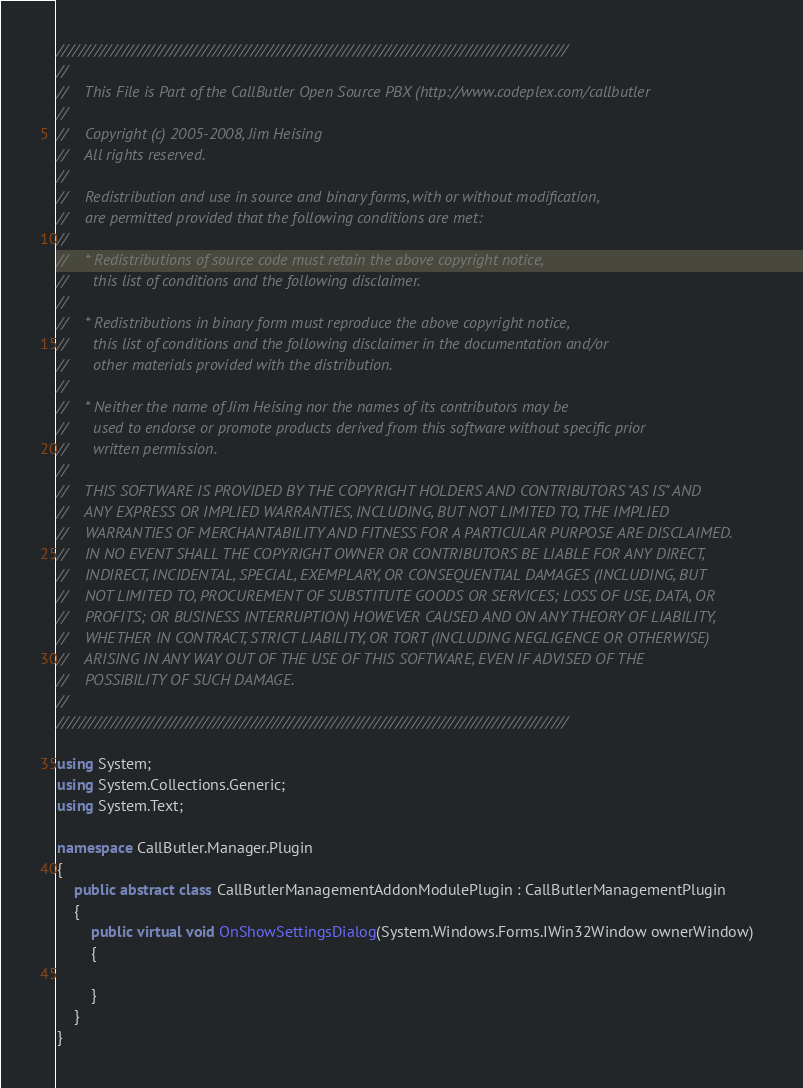<code> <loc_0><loc_0><loc_500><loc_500><_C#_>///////////////////////////////////////////////////////////////////////////////////////////////
//
//    This File is Part of the CallButler Open Source PBX (http://www.codeplex.com/callbutler
//
//    Copyright (c) 2005-2008, Jim Heising
//    All rights reserved.
//
//    Redistribution and use in source and binary forms, with or without modification,
//    are permitted provided that the following conditions are met:
//
//    * Redistributions of source code must retain the above copyright notice,
//      this list of conditions and the following disclaimer.
//
//    * Redistributions in binary form must reproduce the above copyright notice,
//      this list of conditions and the following disclaimer in the documentation and/or
//      other materials provided with the distribution.
//
//    * Neither the name of Jim Heising nor the names of its contributors may be
//      used to endorse or promote products derived from this software without specific prior
//      written permission.
//
//    THIS SOFTWARE IS PROVIDED BY THE COPYRIGHT HOLDERS AND CONTRIBUTORS "AS IS" AND
//    ANY EXPRESS OR IMPLIED WARRANTIES, INCLUDING, BUT NOT LIMITED TO, THE IMPLIED
//    WARRANTIES OF MERCHANTABILITY AND FITNESS FOR A PARTICULAR PURPOSE ARE DISCLAIMED.
//    IN NO EVENT SHALL THE COPYRIGHT OWNER OR CONTRIBUTORS BE LIABLE FOR ANY DIRECT,
//    INDIRECT, INCIDENTAL, SPECIAL, EXEMPLARY, OR CONSEQUENTIAL DAMAGES (INCLUDING, BUT
//    NOT LIMITED TO, PROCUREMENT OF SUBSTITUTE GOODS OR SERVICES; LOSS OF USE, DATA, OR
//    PROFITS; OR BUSINESS INTERRUPTION) HOWEVER CAUSED AND ON ANY THEORY OF LIABILITY,
//    WHETHER IN CONTRACT, STRICT LIABILITY, OR TORT (INCLUDING NEGLIGENCE OR OTHERWISE)
//    ARISING IN ANY WAY OUT OF THE USE OF THIS SOFTWARE, EVEN IF ADVISED OF THE
//    POSSIBILITY OF SUCH DAMAGE.
//
///////////////////////////////////////////////////////////////////////////////////////////////

using System;
using System.Collections.Generic;
using System.Text;

namespace CallButler.Manager.Plugin
{
    public abstract class CallButlerManagementAddonModulePlugin : CallButlerManagementPlugin
    {
        public virtual void OnShowSettingsDialog(System.Windows.Forms.IWin32Window ownerWindow)
        {
            
        }
    }
}
</code> 